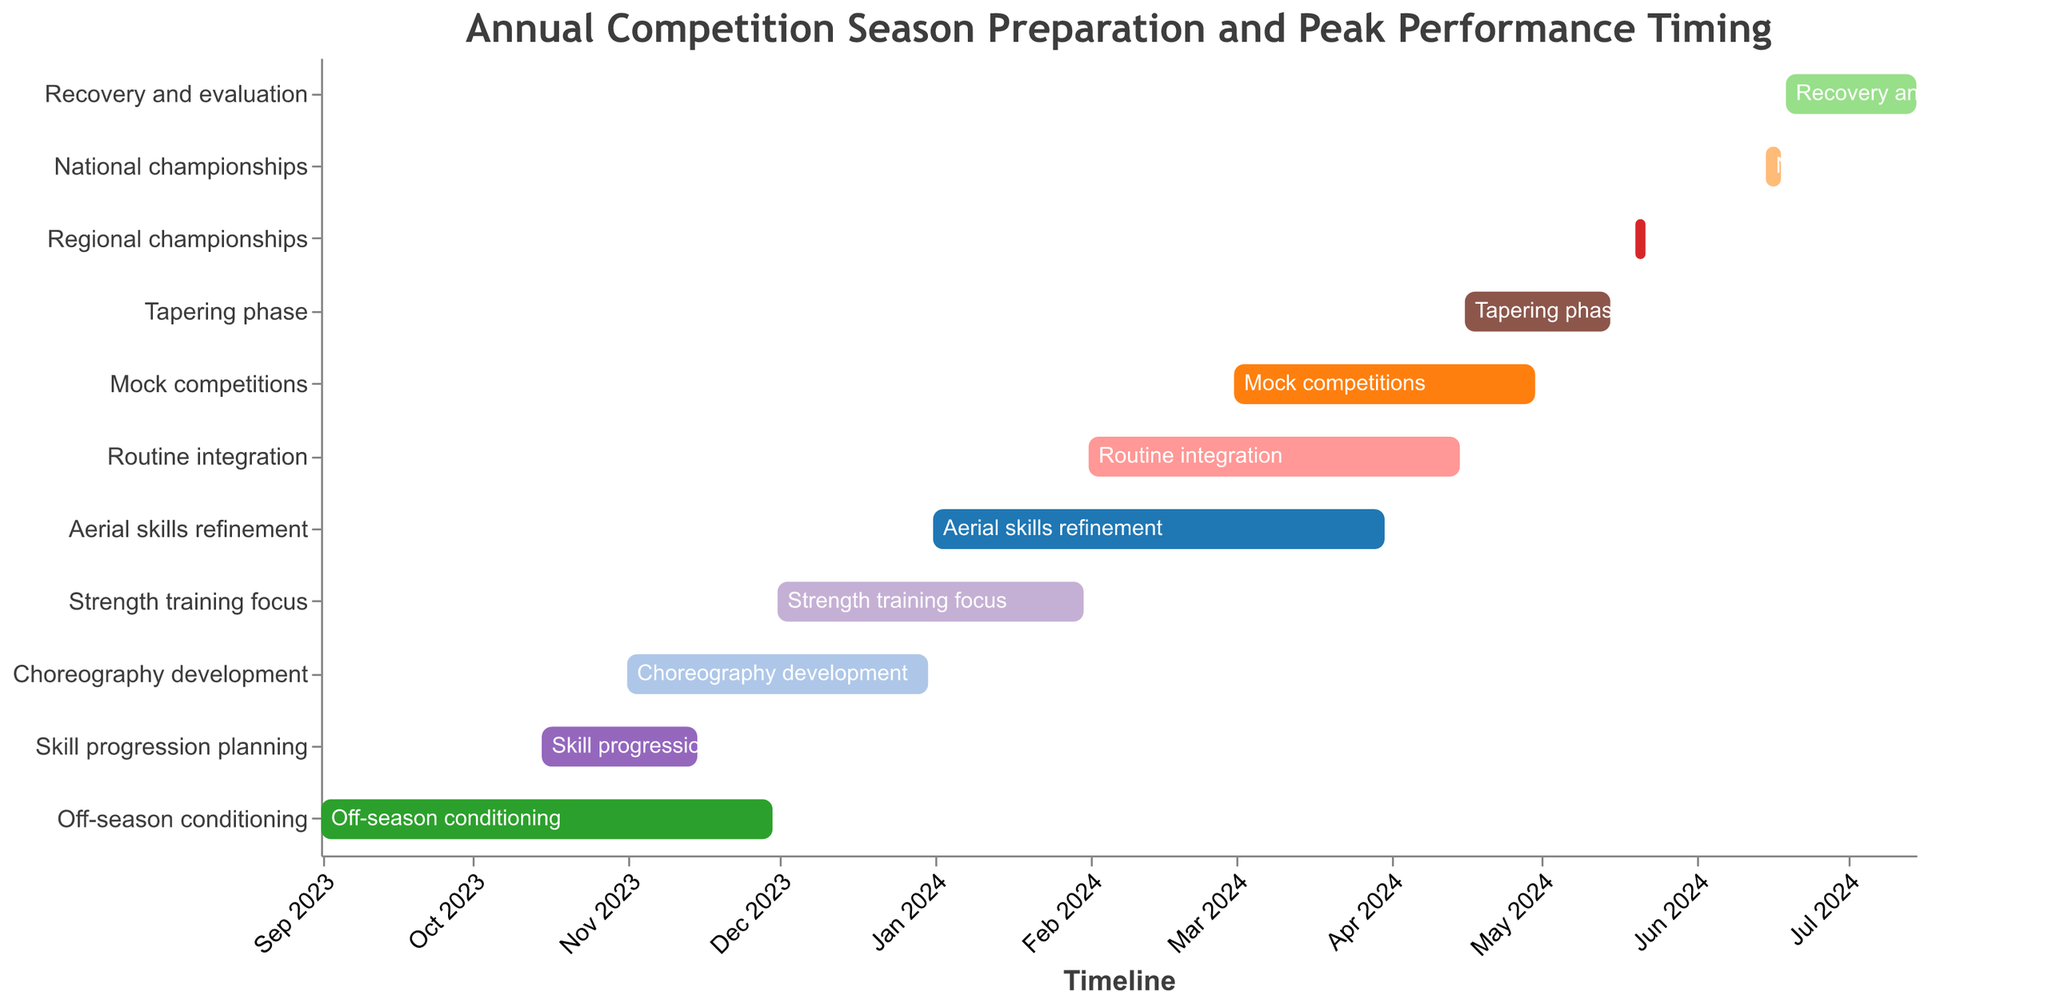Which task has the longest duration in the Gantt chart? The task with the longest duration can be determined by comparing the start and end dates for each task. "Choreography development" runs from November 1, 2023, to December 31, 2023, which is about two months, making it the longest.
Answer: Choreography development When does the "Aerial skills refinement" task start and end? The "Aerial skills refinement" task starts on January 1, 2024, and ends on March 31, 2024, as indicated by the start and end dates on its bar in the Gantt chart.
Answer: January 1, 2024, to March 31, 2024 Which tasks overlap with "Strength training focus"? To find overlaps, we need to identify tasks whose date ranges intersect with "Strength training focus" (December 1, 2023, to January 31, 2024). The overlapping tasks are "Choreography development," "Aerial skills refinement," and "Skill progression planning."
Answer: Choreography development, Aerial skills refinement What is the duration of the "Tapering phase"? Duration is computed by finding the difference between end and start dates. The "Tapering phase" starts on April 16, 2024, and ends on May 15, 2024. The duration is 30 days.
Answer: 30 days Which activities are scheduled after the "National championships"? Activities scheduled after the "National championships" (June 15, 2024, to June 18, 2024) are "Recovery and evaluation."
Answer: Recovery and evaluation How many tasks occur simultaneously in March 2024? Identify tasks with date ranges that include March 2024. These tasks are "Strength training focus," "Aerial skills refinement," "Routine integration," and "Mock competitions," making it a total of four tasks.
Answer: 4 tasks Are there any tasks that span more than two months? To determine this, check tasks with durations over two months. "Choreography development" (Nov 1, 2023, to Dec 31, 2023) fits this criterion, spanning exactly two months. No tasks exceed this duration.
Answer: No What is the focus immediately after "Off-season conditioning"? The next task after "Off-season conditioning" (Sep 1, 2023, to Nov 30, 2023) is "Skill progression planning" which starts on October 15, 2023, and overlaps slightly.
Answer: Skill progression planning Which task is closest in time to the "National championships"? The closest task to the "National championships" (June 15, 2024 - June 18, 2024) is "Recovery and evaluation" which starts immediately after on June 19, 2024.
Answer: Recovery and evaluation 